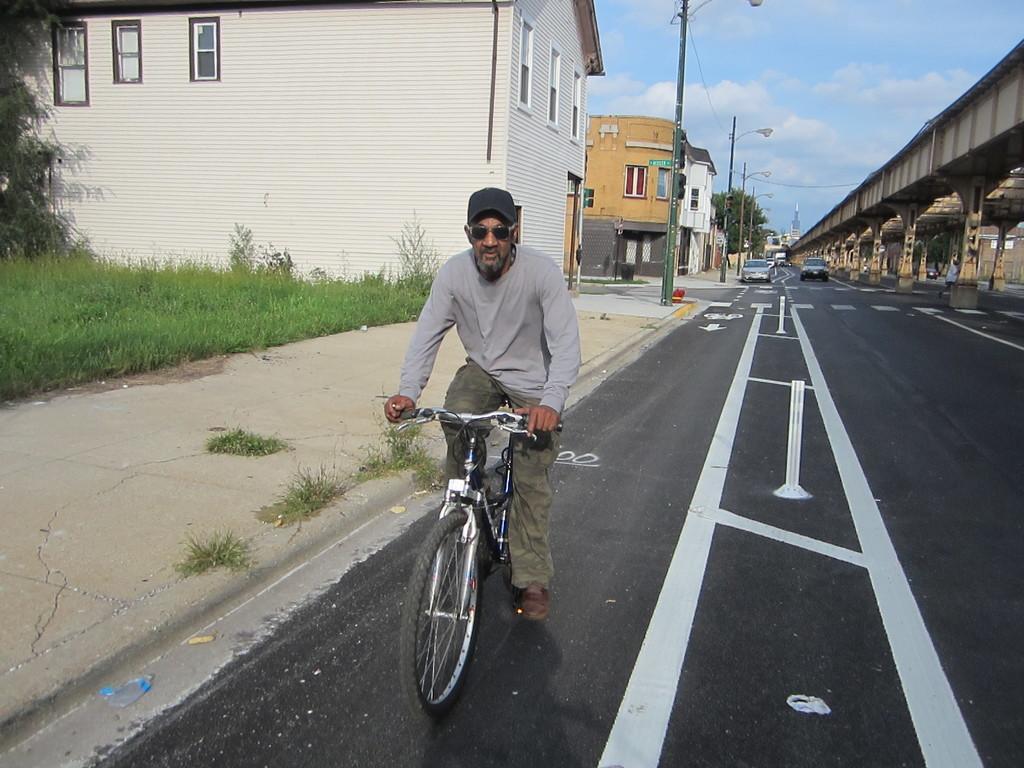How would you summarize this image in a sentence or two? In this image we have a man riding a bicycle and in background we have grass , building , street light , car and a bridge. 